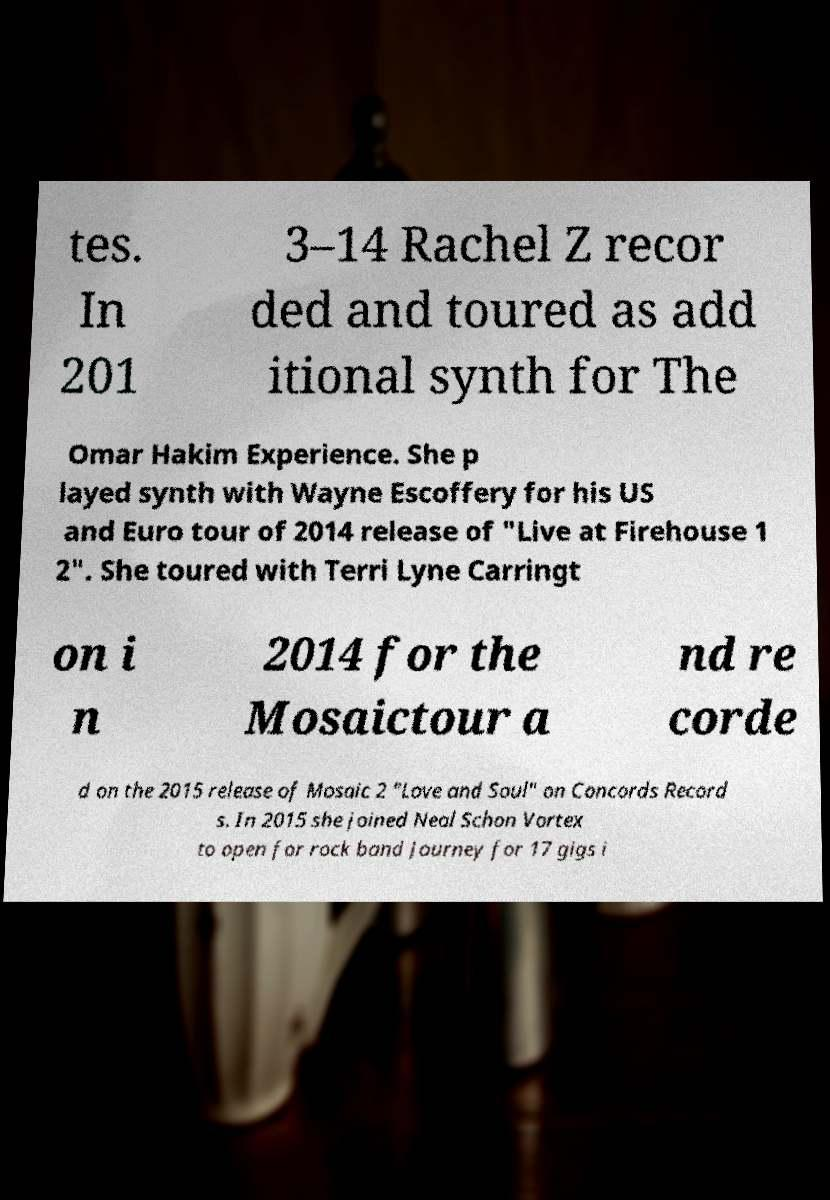For documentation purposes, I need the text within this image transcribed. Could you provide that? tes. In 201 3–14 Rachel Z recor ded and toured as add itional synth for The Omar Hakim Experience. She p layed synth with Wayne Escoffery for his US and Euro tour of 2014 release of "Live at Firehouse 1 2". She toured with Terri Lyne Carringt on i n 2014 for the Mosaictour a nd re corde d on the 2015 release of Mosaic 2 "Love and Soul" on Concords Record s. In 2015 she joined Neal Schon Vortex to open for rock band Journey for 17 gigs i 